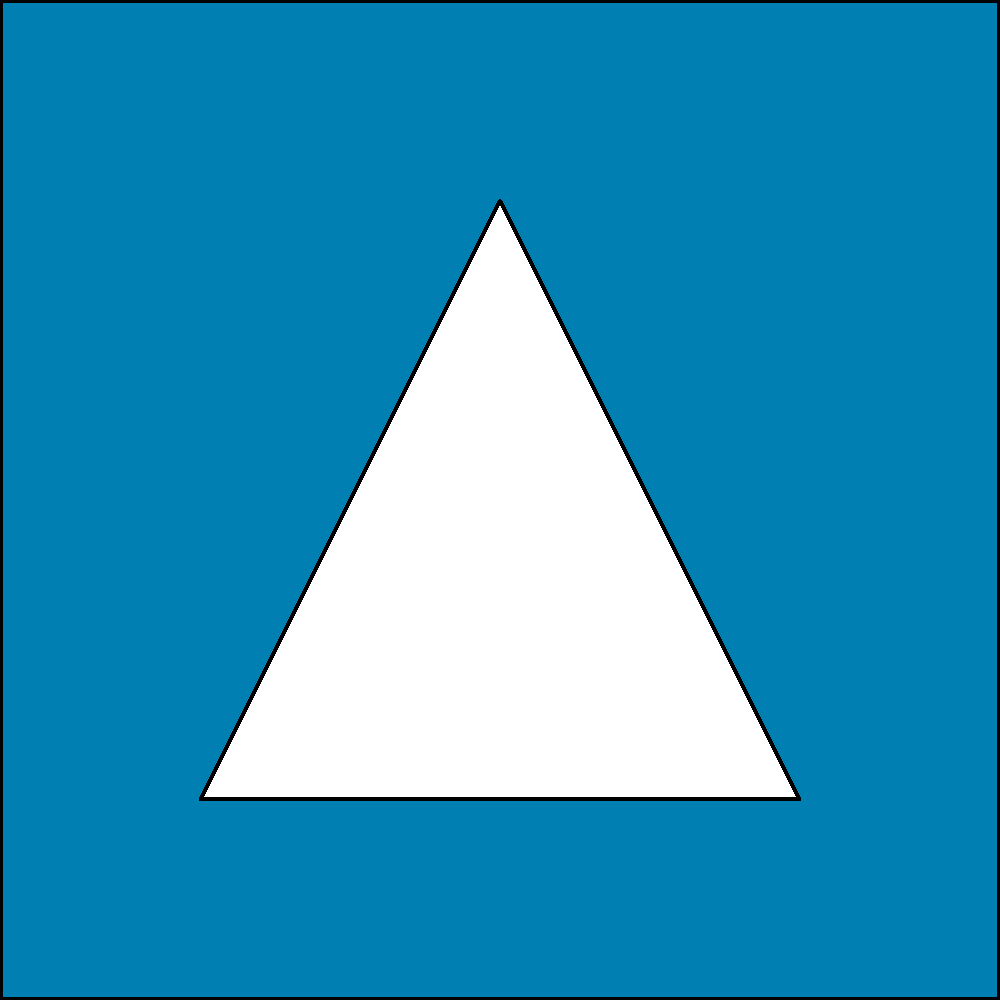The logo of a popular SUV brand is represented by a square with an equilateral triangle inside. Considering this logo as a representation of the dihedral group $D_4$, how many symmetries does this logo have? To determine the number of symmetries in this logo, we need to consider the dihedral group $D_4$, which represents the symmetries of a square. Let's break it down step-by-step:

1. Rotational symmetries:
   - The square can be rotated by 0°, 90°, 180°, and 270°.
   - This gives us 4 rotational symmetries.

2. Reflection symmetries:
   - The square has 4 lines of reflection: 2 diagonal and 2 through the midpoints of opposite sides.
   - However, the equilateral triangle inside the square reduces the number of reflection symmetries.
   - Only the vertical and horizontal reflections through the midpoints preserve the triangle's orientation.

3. Total symmetries:
   - 4 rotational symmetries (including the identity rotation)
   - 2 reflection symmetries (vertical and horizontal)
   - 4 + 2 = 6 total symmetries

Therefore, the logo has 6 symmetries when considered as a representation of the dihedral group $D_4$.
Answer: 6 symmetries 